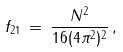Convert formula to latex. <formula><loc_0><loc_0><loc_500><loc_500>f _ { 2 1 } \, = \, \frac { N ^ { 2 } } { 1 6 ( 4 \pi ^ { 2 } ) ^ { 2 } } \, ,</formula> 